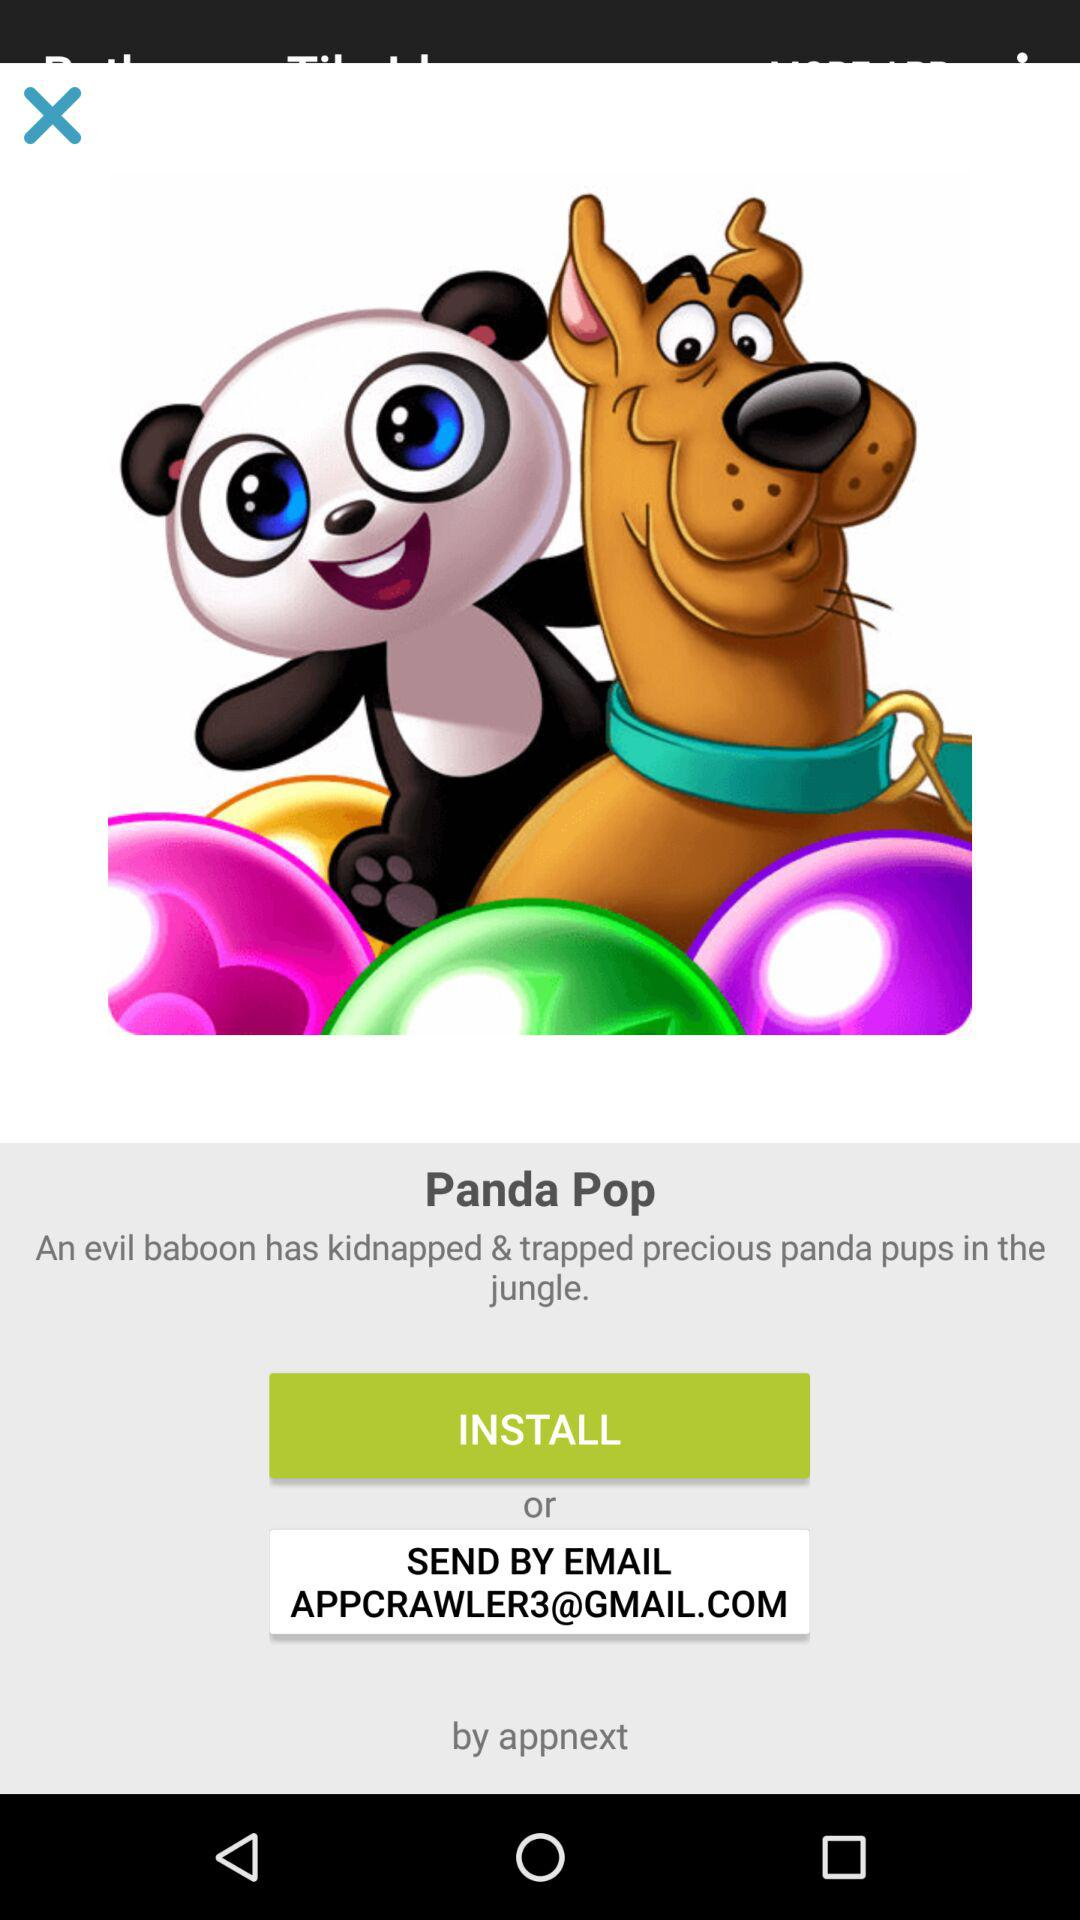What's the Gmail address? The Gmail address is APPCRAWLER3@GMAIL.COM. 